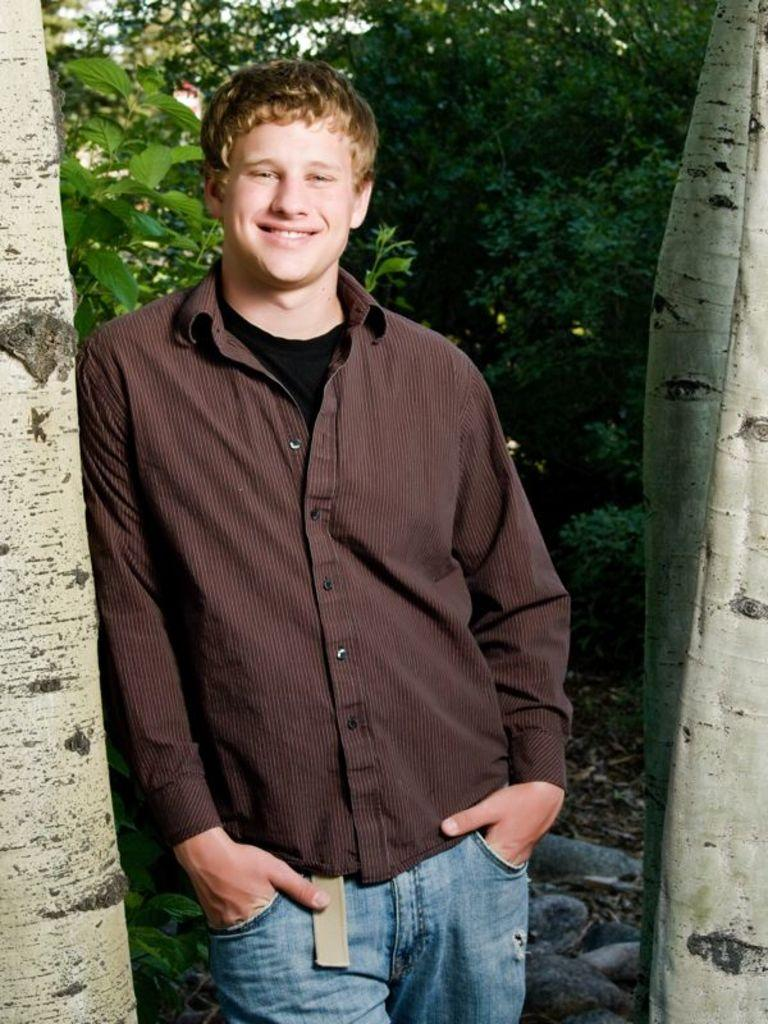What is the main subject in the foreground of the picture? There is a person in the foreground of the picture. What is the person wearing? The person is wearing a shirt. What is the person's facial expression? The person is smiling. What is the person's posture in the picture? The person is standing. What can be seen in the background of the picture? There are trees and other objects in the background of the picture. Can you see any guns in the person's hand in the image? There are no guns visible in the person's hand or anywhere else in the image. What type of plantation is visible in the background of the image? There is no plantation present in the background of the image; it features trees and other objects. 